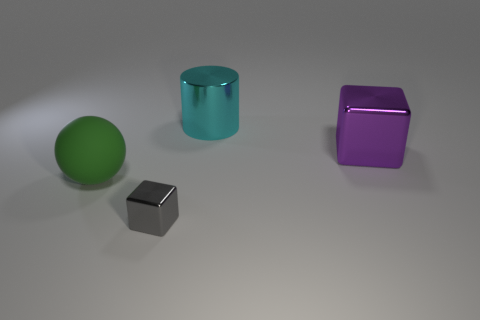Add 4 big cyan objects. How many objects exist? 8 Subtract all cylinders. How many objects are left? 3 Subtract 0 cyan cubes. How many objects are left? 4 Subtract all small brown cylinders. Subtract all gray objects. How many objects are left? 3 Add 1 cyan metallic things. How many cyan metallic things are left? 2 Add 3 big cyan cylinders. How many big cyan cylinders exist? 4 